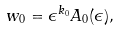<formula> <loc_0><loc_0><loc_500><loc_500>w _ { 0 } = \epsilon ^ { k _ { 0 } } A _ { 0 } ( \epsilon ) ,</formula> 